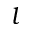<formula> <loc_0><loc_0><loc_500><loc_500>l</formula> 